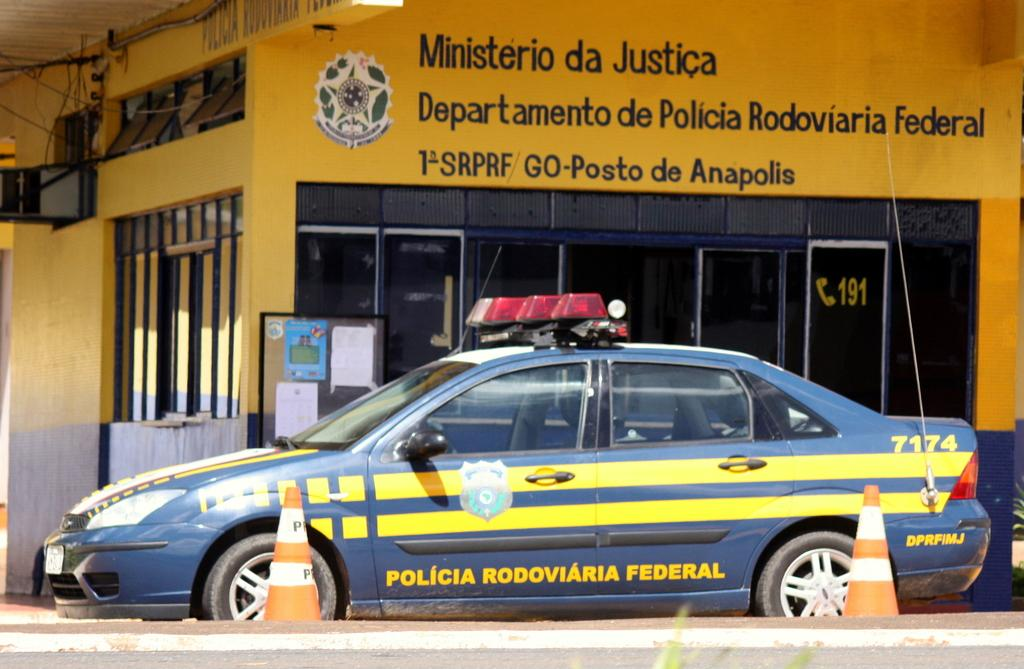What is the main subject in the center of the image? There is a car in the center of the image. What objects can be seen near the car? There are traffic poles in the image. What can be seen in the background of the image? There is a building, a wall, a roof, a banner, glass, a board, and posters in the background of the image. What type of arch can be seen in the image? There is no arch present in the image. What form of transportation is used by the astronauts in the image? There are no astronauts or space-related elements present in the image. 